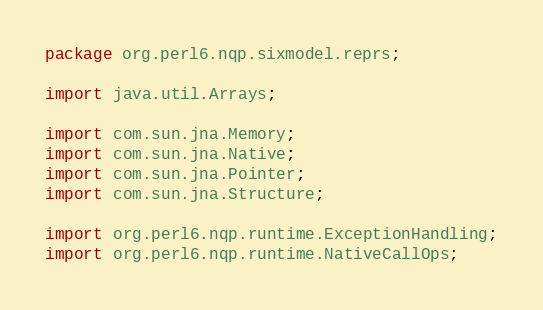Convert code to text. <code><loc_0><loc_0><loc_500><loc_500><_Java_>package org.perl6.nqp.sixmodel.reprs;

import java.util.Arrays;

import com.sun.jna.Memory;
import com.sun.jna.Native;
import com.sun.jna.Pointer;
import com.sun.jna.Structure;

import org.perl6.nqp.runtime.ExceptionHandling;
import org.perl6.nqp.runtime.NativeCallOps;</code> 